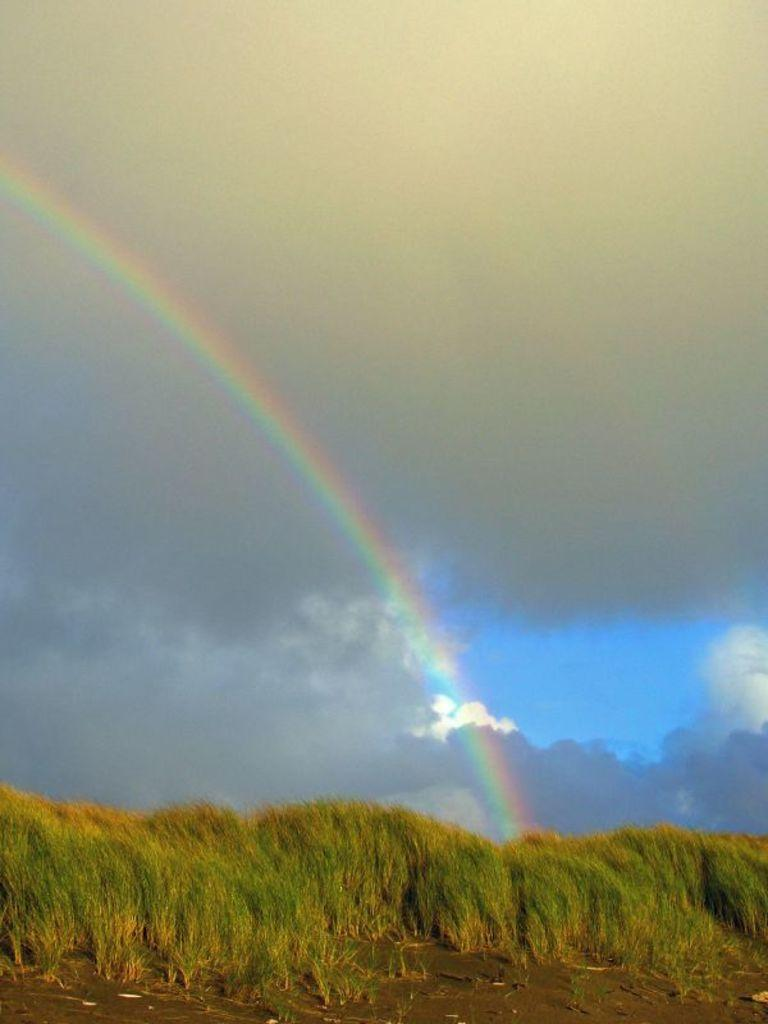What type of vegetation is present on the land in the image? There is grass on the land in the image. What is visible at the top of the image? The sky is visible at the top of the image. What can be seen in the sky? Clouds are present in the sky. What additional feature is visible on the left side of the image? A rainbow is visible on the left side of the image. What type of chair is present in the image? There is no chair present in the image. What effect does the pen have on the grass in the image? There is no pen present in the image, so it cannot have any effect on the grass. 